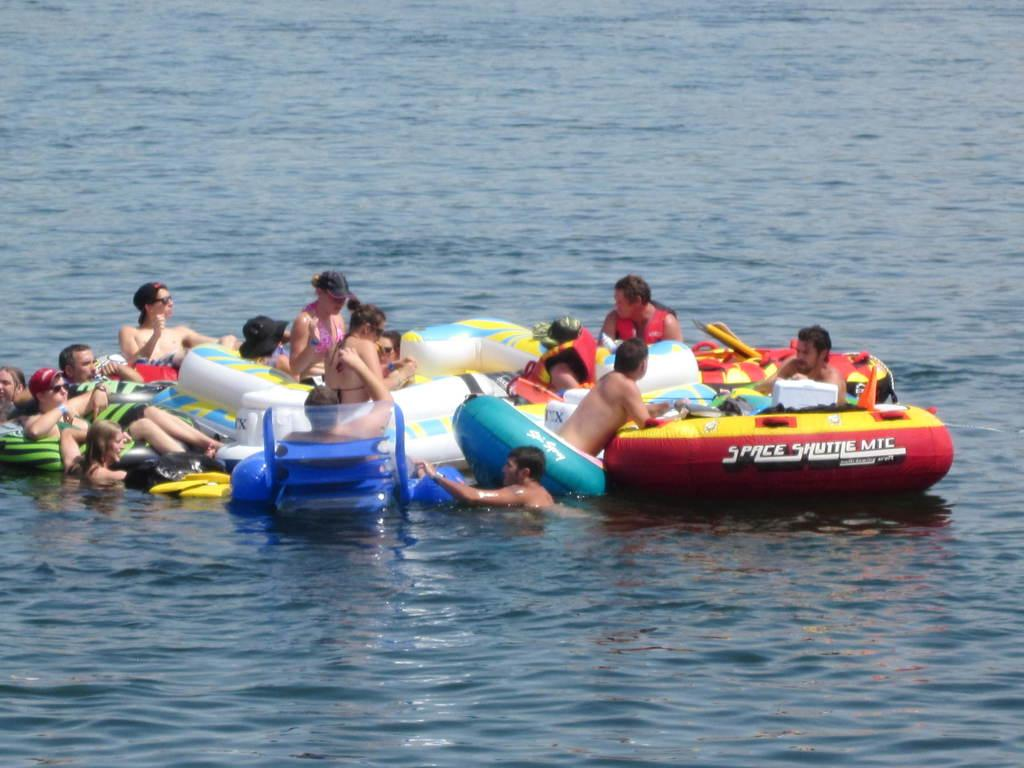What are the people in the image doing? The people in the image are sitting in tubes. What can be seen in the image besides the people? There is water visible in the image. How many rabbits can be seen in the image? There are no rabbits present in the image. What type of boot is being used in the operation? There is no mention of a boot or any operation in the image. 